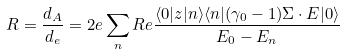<formula> <loc_0><loc_0><loc_500><loc_500>R = \frac { d _ { A } } { d _ { e } } = 2 e \sum _ { n } R e \frac { \langle 0 | z | n \rangle \langle n | ( \gamma _ { 0 } - 1 ) { \Sigma } \cdot { E } | 0 \rangle } { E _ { 0 } - E _ { n } }</formula> 